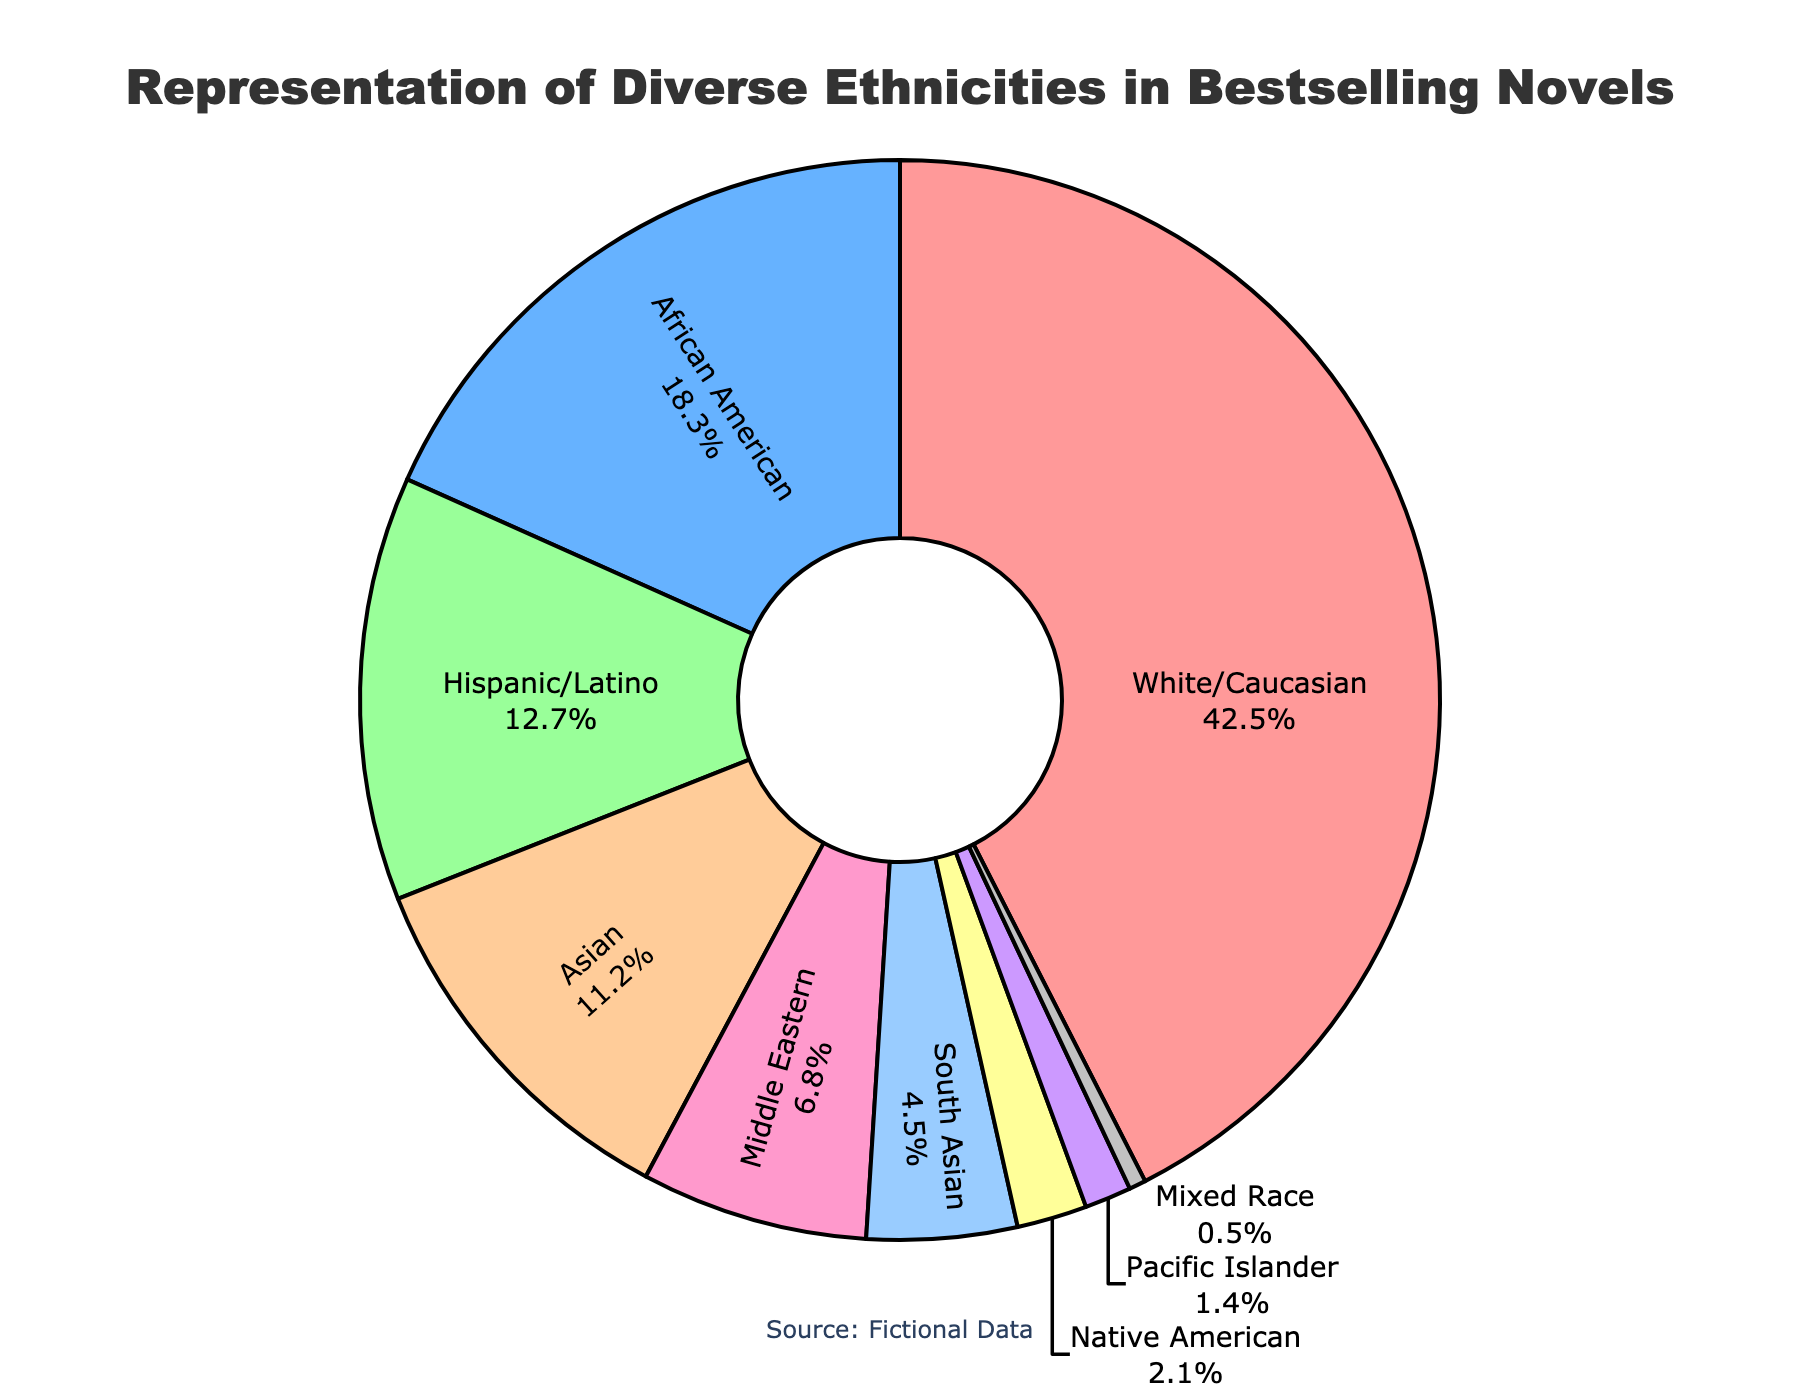What percentage of bestselling novels are represented by Hispanic/Latino authors? Look at the 'Hispanic/Latino' segment of the pie chart; the percentage value indicated is 12.7%.
Answer: 12.7% Which ethnicity has the highest representation in bestselling novels? Look for the largest segment in the pie chart, which is labeled 'White/Caucasian' with a percentage of 42.5%.
Answer: White/Caucasian Compare the representation of African American authors to South Asian authors. Which is greater and by how much? The percentage for African American is 18.3% and for South Asian is 4.5%. Subtract 4.5 from 18.3 to find the difference.
Answer: African American by 13.8% What is the combined representation of Native American and Pacific Islander authors? Add the percentages for Native American (2.1%) and Pacific Islander (1.4%). This equals 2.1 + 1.4.
Answer: 3.5% Which ethnicities have less than 10% representation in bestselling novels? Identify the segments that are less than 10%. These are: Mixed Race (0.5%), Pacific Islander (1.4%), Native American (2.1%), South Asian (4.5%), and Middle Eastern (6.8%).
Answer: Mixed Race, Pacific Islander, Native American, South Asian, Middle Eastern How much more representation do White/Caucasian authors have compared to Asian authors? Subtract the percentage of Asian authors (11.2%) from that of White/Caucasian authors (42.5%). This equals 42.5 - 11.2.
Answer: 31.3% Among the shown ethnicities, which has the least representation in bestselling novels? Look for the smallest segment in the pie chart, which is labeled 'Mixed Race' with a percentage of 0.5%.
Answer: Mixed Race What is the percentage difference between the representation of Hispanic/Latino and Middle Eastern authors? Subtract the percentage of Middle Eastern authors (6.8%) from that of Hispanic/Latino authors (12.7%). This equals 12.7 - 6.8.
Answer: 5.9% What is the total representation of African American, Hispanic/Latino, and Asian authors combined? Add the percentages for African American (18.3%), Hispanic/Latino (12.7%), and Asian (11.2%). This equals 18.3 + 12.7 + 11.2.
Answer: 42.2% 